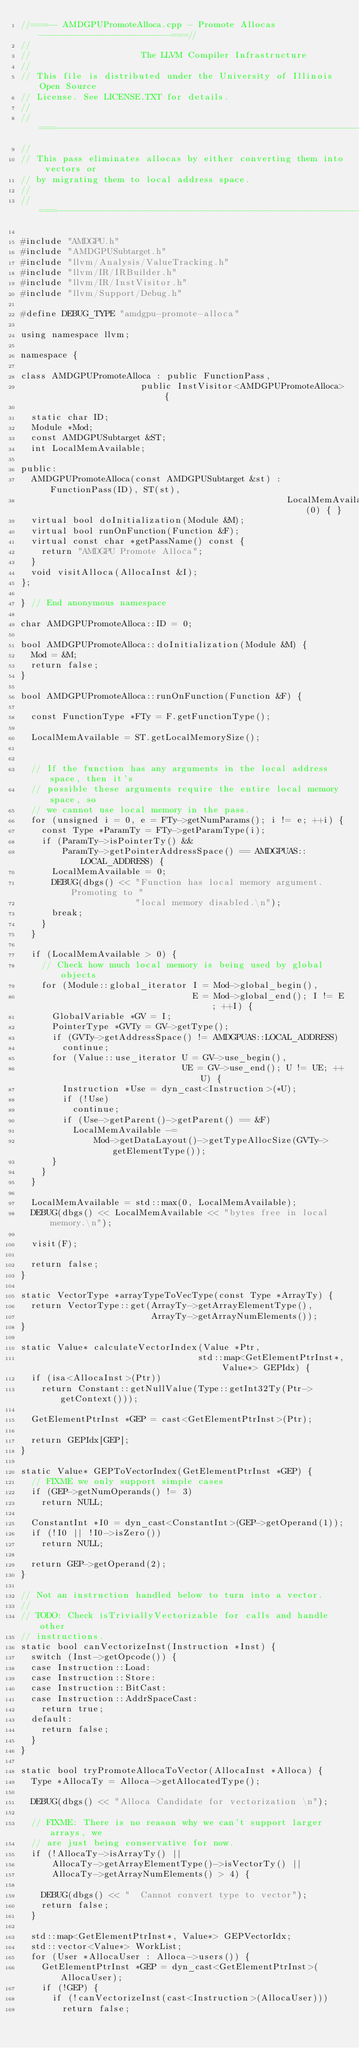<code> <loc_0><loc_0><loc_500><loc_500><_C++_>//===-- AMDGPUPromoteAlloca.cpp - Promote Allocas -------------------------===//
//
//                     The LLVM Compiler Infrastructure
//
// This file is distributed under the University of Illinois Open Source
// License. See LICENSE.TXT for details.
//
//===----------------------------------------------------------------------===//
//
// This pass eliminates allocas by either converting them into vectors or
// by migrating them to local address space.
//
//===----------------------------------------------------------------------===//

#include "AMDGPU.h"
#include "AMDGPUSubtarget.h"
#include "llvm/Analysis/ValueTracking.h"
#include "llvm/IR/IRBuilder.h"
#include "llvm/IR/InstVisitor.h"
#include "llvm/Support/Debug.h"

#define DEBUG_TYPE "amdgpu-promote-alloca"

using namespace llvm;

namespace {

class AMDGPUPromoteAlloca : public FunctionPass,
                       public InstVisitor<AMDGPUPromoteAlloca> {

  static char ID;
  Module *Mod;
  const AMDGPUSubtarget &ST;
  int LocalMemAvailable;

public:
  AMDGPUPromoteAlloca(const AMDGPUSubtarget &st) : FunctionPass(ID), ST(st),
                                                   LocalMemAvailable(0) { }
  virtual bool doInitialization(Module &M);
  virtual bool runOnFunction(Function &F);
  virtual const char *getPassName() const {
    return "AMDGPU Promote Alloca";
  }
  void visitAlloca(AllocaInst &I);
};

} // End anonymous namespace

char AMDGPUPromoteAlloca::ID = 0;

bool AMDGPUPromoteAlloca::doInitialization(Module &M) {
  Mod = &M;
  return false;
}

bool AMDGPUPromoteAlloca::runOnFunction(Function &F) {

  const FunctionType *FTy = F.getFunctionType();

  LocalMemAvailable = ST.getLocalMemorySize();


  // If the function has any arguments in the local address space, then it's
  // possible these arguments require the entire local memory space, so
  // we cannot use local memory in the pass.
  for (unsigned i = 0, e = FTy->getNumParams(); i != e; ++i) {
    const Type *ParamTy = FTy->getParamType(i);
    if (ParamTy->isPointerTy() &&
        ParamTy->getPointerAddressSpace() == AMDGPUAS::LOCAL_ADDRESS) {
      LocalMemAvailable = 0;
      DEBUG(dbgs() << "Function has local memory argument.  Promoting to "
                      "local memory disabled.\n");
      break;
    }
  }

  if (LocalMemAvailable > 0) {
    // Check how much local memory is being used by global objects
    for (Module::global_iterator I = Mod->global_begin(),
                                 E = Mod->global_end(); I != E; ++I) {
      GlobalVariable *GV = I;
      PointerType *GVTy = GV->getType();
      if (GVTy->getAddressSpace() != AMDGPUAS::LOCAL_ADDRESS)
        continue;
      for (Value::use_iterator U = GV->use_begin(),
                               UE = GV->use_end(); U != UE; ++U) {
        Instruction *Use = dyn_cast<Instruction>(*U);
        if (!Use)
          continue;
        if (Use->getParent()->getParent() == &F)
          LocalMemAvailable -=
              Mod->getDataLayout()->getTypeAllocSize(GVTy->getElementType());
      }
    }
  }

  LocalMemAvailable = std::max(0, LocalMemAvailable);
  DEBUG(dbgs() << LocalMemAvailable << "bytes free in local memory.\n");

  visit(F);

  return false;
}

static VectorType *arrayTypeToVecType(const Type *ArrayTy) {
  return VectorType::get(ArrayTy->getArrayElementType(),
                         ArrayTy->getArrayNumElements());
}

static Value* calculateVectorIndex(Value *Ptr,
                                  std::map<GetElementPtrInst*, Value*> GEPIdx) {
  if (isa<AllocaInst>(Ptr))
    return Constant::getNullValue(Type::getInt32Ty(Ptr->getContext()));

  GetElementPtrInst *GEP = cast<GetElementPtrInst>(Ptr);

  return GEPIdx[GEP];
}

static Value* GEPToVectorIndex(GetElementPtrInst *GEP) {
  // FIXME we only support simple cases
  if (GEP->getNumOperands() != 3)
    return NULL;

  ConstantInt *I0 = dyn_cast<ConstantInt>(GEP->getOperand(1));
  if (!I0 || !I0->isZero())
    return NULL;

  return GEP->getOperand(2);
}

// Not an instruction handled below to turn into a vector.
//
// TODO: Check isTriviallyVectorizable for calls and handle other
// instructions.
static bool canVectorizeInst(Instruction *Inst) {
  switch (Inst->getOpcode()) {
  case Instruction::Load:
  case Instruction::Store:
  case Instruction::BitCast:
  case Instruction::AddrSpaceCast:
    return true;
  default:
    return false;
  }
}

static bool tryPromoteAllocaToVector(AllocaInst *Alloca) {
  Type *AllocaTy = Alloca->getAllocatedType();

  DEBUG(dbgs() << "Alloca Candidate for vectorization \n");

  // FIXME: There is no reason why we can't support larger arrays, we
  // are just being conservative for now.
  if (!AllocaTy->isArrayTy() ||
      AllocaTy->getArrayElementType()->isVectorTy() ||
      AllocaTy->getArrayNumElements() > 4) {

    DEBUG(dbgs() << "  Cannot convert type to vector");
    return false;
  }

  std::map<GetElementPtrInst*, Value*> GEPVectorIdx;
  std::vector<Value*> WorkList;
  for (User *AllocaUser : Alloca->users()) {
    GetElementPtrInst *GEP = dyn_cast<GetElementPtrInst>(AllocaUser);
    if (!GEP) {
      if (!canVectorizeInst(cast<Instruction>(AllocaUser)))
        return false;
</code> 